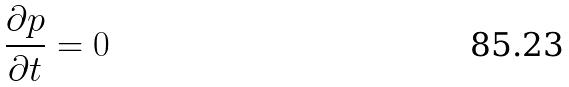Convert formula to latex. <formula><loc_0><loc_0><loc_500><loc_500>\frac { \partial p } { \partial t } = 0</formula> 